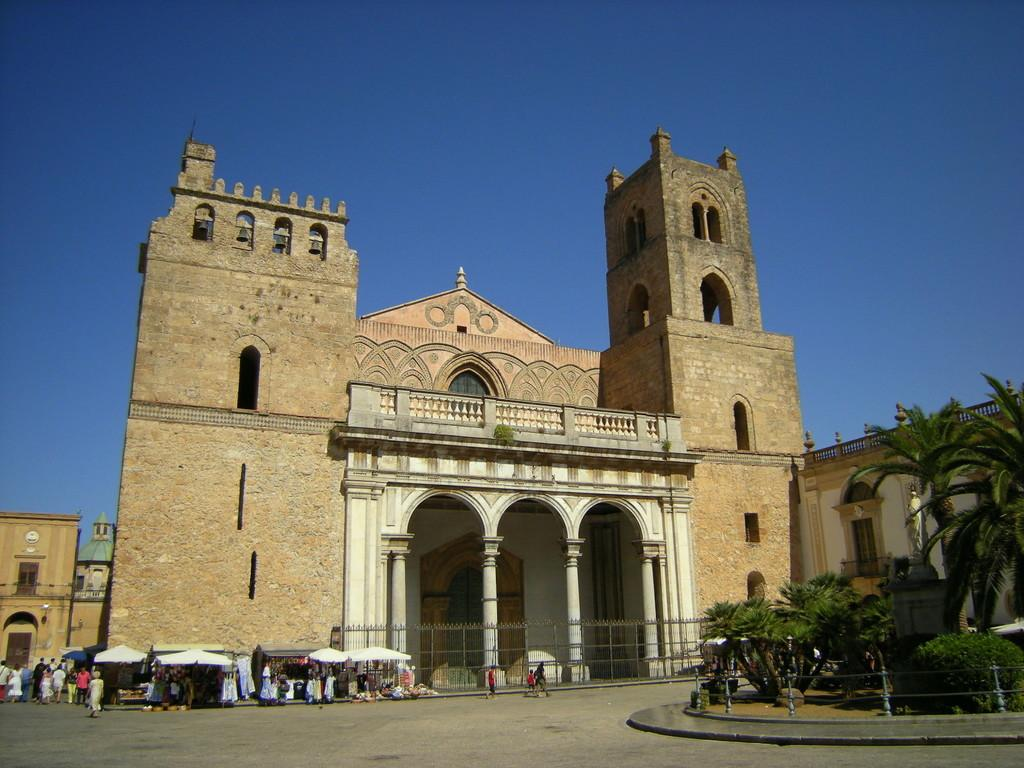What type of structures can be seen in the image? There are buildings in the image. What else can be found in the image besides buildings? There are trees and a group of people in the image. What are the tents used for in the image? The tents are in front of the building, possibly for an event or gathering. What material is used for the rods in the image? Metal rods are present in the image. What type of agreement is being signed by the people in the image? There is no indication of a signing or agreement in the image; it only shows buildings, trees, a group of people, tents, and metal rods. 